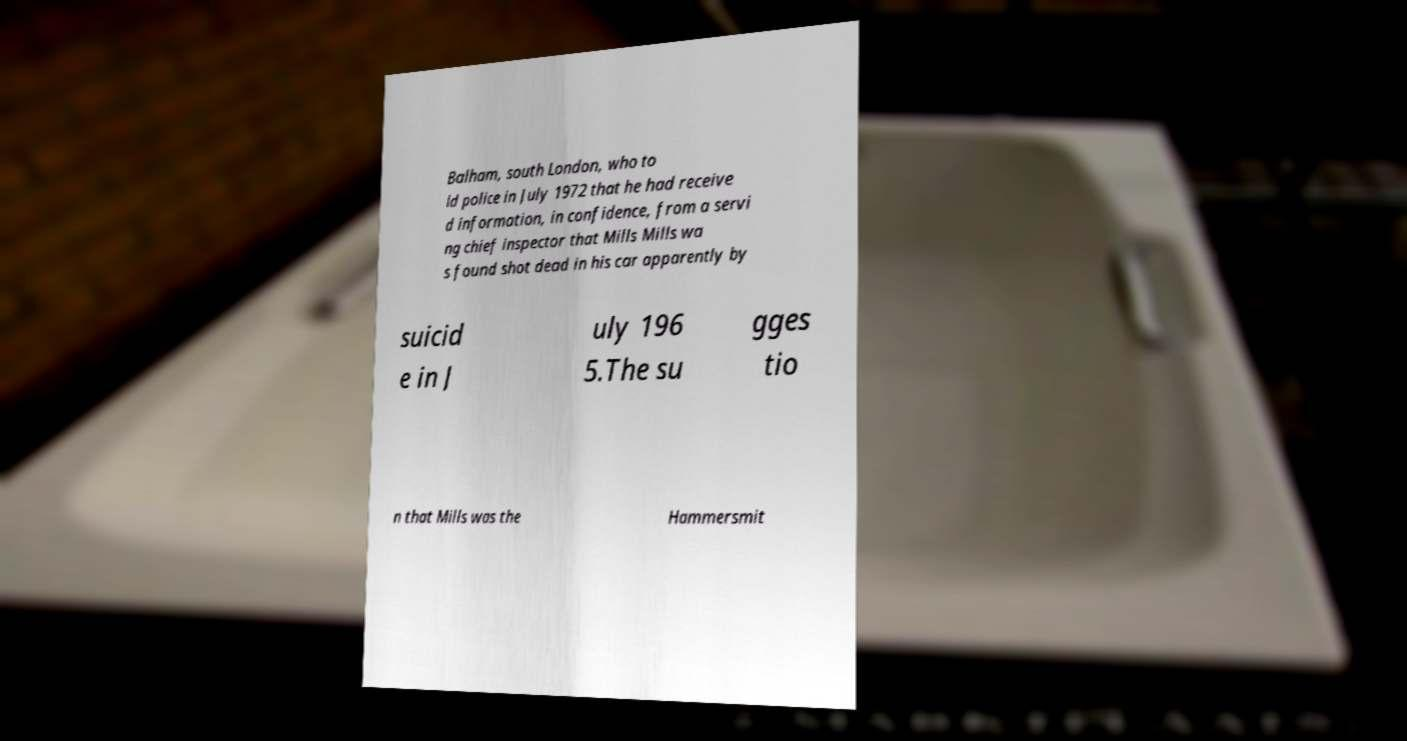There's text embedded in this image that I need extracted. Can you transcribe it verbatim? Balham, south London, who to ld police in July 1972 that he had receive d information, in confidence, from a servi ng chief inspector that Mills Mills wa s found shot dead in his car apparently by suicid e in J uly 196 5.The su gges tio n that Mills was the Hammersmit 